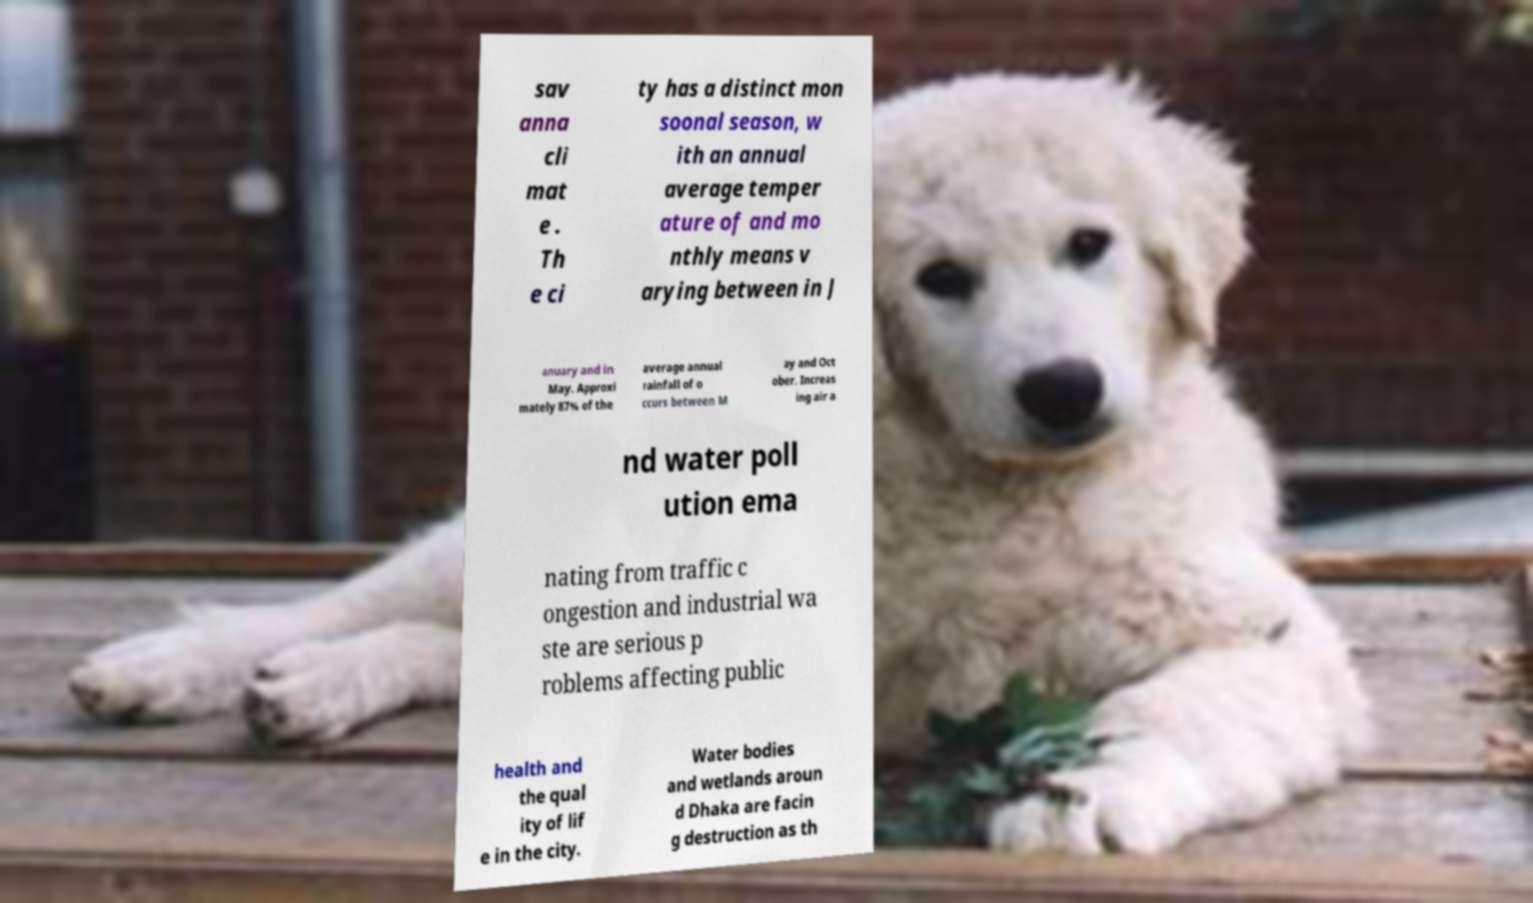Please read and relay the text visible in this image. What does it say? sav anna cli mat e . Th e ci ty has a distinct mon soonal season, w ith an annual average temper ature of and mo nthly means v arying between in J anuary and in May. Approxi mately 87% of the average annual rainfall of o ccurs between M ay and Oct ober. Increas ing air a nd water poll ution ema nating from traffic c ongestion and industrial wa ste are serious p roblems affecting public health and the qual ity of lif e in the city. Water bodies and wetlands aroun d Dhaka are facin g destruction as th 